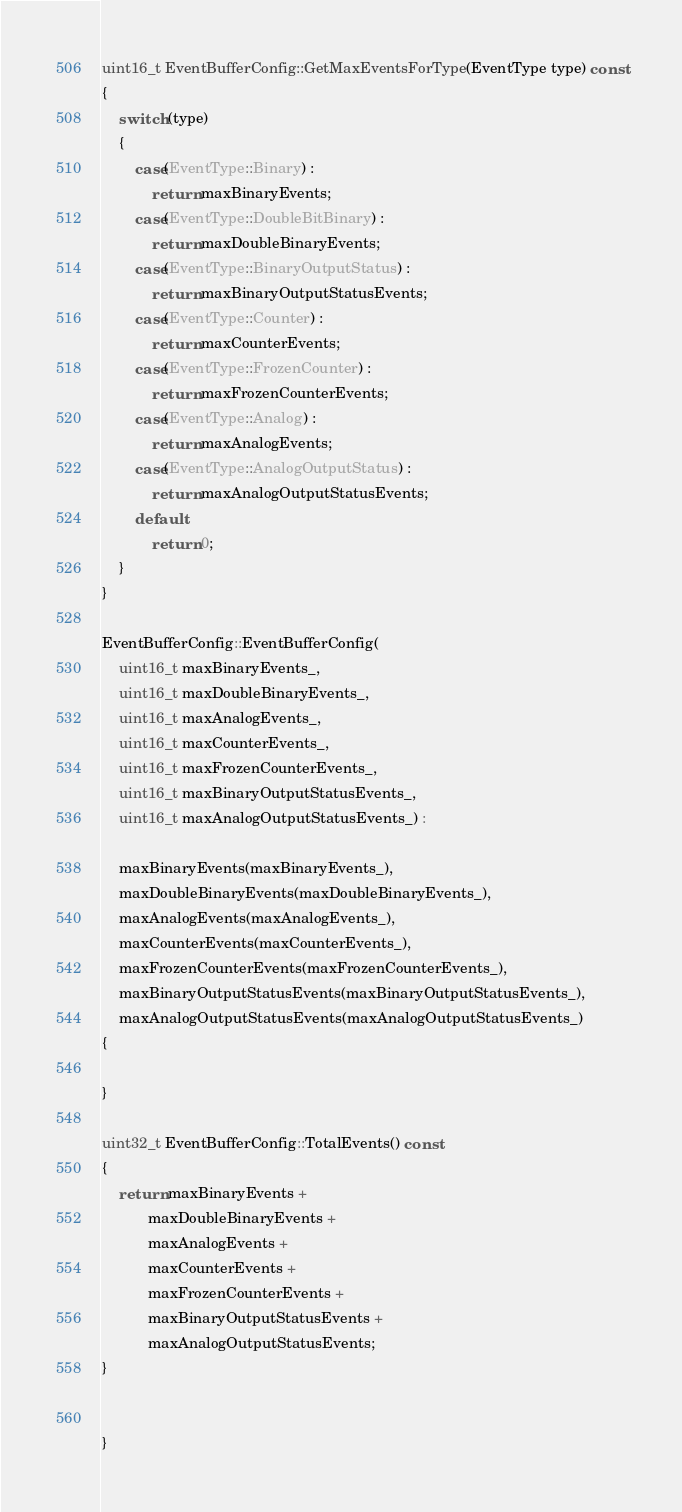<code> <loc_0><loc_0><loc_500><loc_500><_C++_>
uint16_t EventBufferConfig::GetMaxEventsForType(EventType type) const
{
	switch (type)
	{
		case(EventType::Binary) :
			return maxBinaryEvents;
		case(EventType::DoubleBitBinary) :
			return maxDoubleBinaryEvents;
		case(EventType::BinaryOutputStatus) :
			return maxBinaryOutputStatusEvents;
		case(EventType::Counter) :
			return maxCounterEvents;
		case(EventType::FrozenCounter) :
			return maxFrozenCounterEvents;		
		case(EventType::Analog) :
			return maxAnalogEvents;
		case(EventType::AnalogOutputStatus) :
			return maxAnalogOutputStatusEvents;
		default:
			return 0;
	}
}

EventBufferConfig::EventBufferConfig(
    uint16_t maxBinaryEvents_,
    uint16_t maxDoubleBinaryEvents_,
    uint16_t maxAnalogEvents_,
    uint16_t maxCounterEvents_,
    uint16_t maxFrozenCounterEvents_,
    uint16_t maxBinaryOutputStatusEvents_,
    uint16_t maxAnalogOutputStatusEvents_) :

	maxBinaryEvents(maxBinaryEvents_),
	maxDoubleBinaryEvents(maxDoubleBinaryEvents_),
	maxAnalogEvents(maxAnalogEvents_),
	maxCounterEvents(maxCounterEvents_),
	maxFrozenCounterEvents(maxFrozenCounterEvents_),
	maxBinaryOutputStatusEvents(maxBinaryOutputStatusEvents_),
	maxAnalogOutputStatusEvents(maxAnalogOutputStatusEvents_)
{

}

uint32_t EventBufferConfig::TotalEvents() const
{
	return maxBinaryEvents +
	       maxDoubleBinaryEvents +
	       maxAnalogEvents +
	       maxCounterEvents +
	       maxFrozenCounterEvents +
	       maxBinaryOutputStatusEvents +
	       maxAnalogOutputStatusEvents;
}


}

</code> 